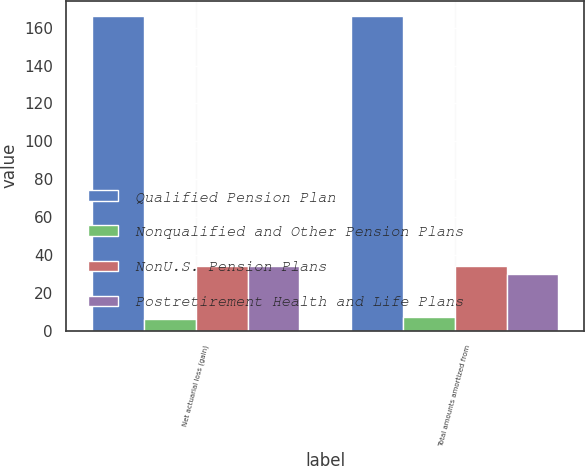Convert chart. <chart><loc_0><loc_0><loc_500><loc_500><stacked_bar_chart><ecel><fcel>Net actuarial loss (gain)<fcel>Total amounts amortized from<nl><fcel>Qualified Pension Plan<fcel>166<fcel>166<nl><fcel>Nonqualified and Other Pension Plans<fcel>6<fcel>7<nl><fcel>NonU.S. Pension Plans<fcel>34<fcel>34<nl><fcel>Postretirement Health and Life Plans<fcel>34<fcel>30<nl></chart> 